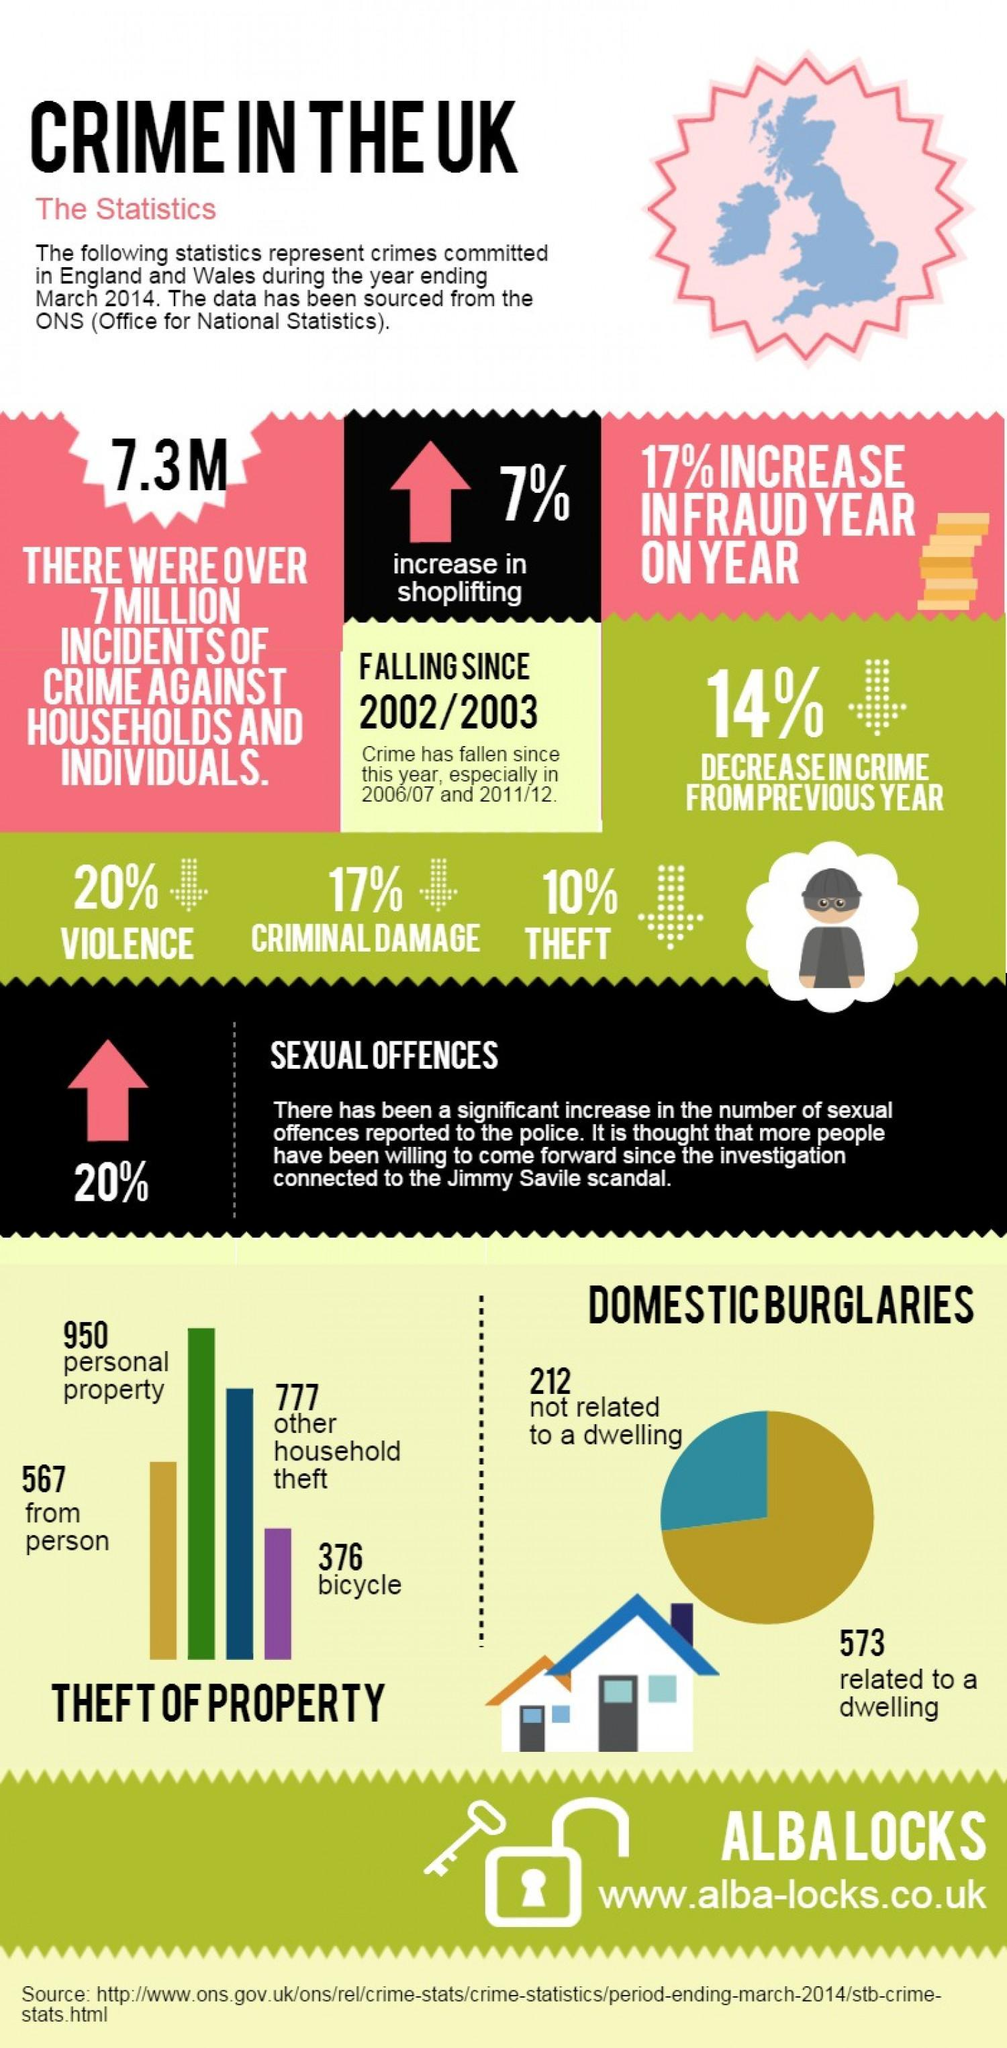How much is the percentage decrease in criminal damage?
Answer the question with a short phrase. 17% What is the percentage increase in fraud year on year? 17% Among the theft propery how many are theft from person? 567 